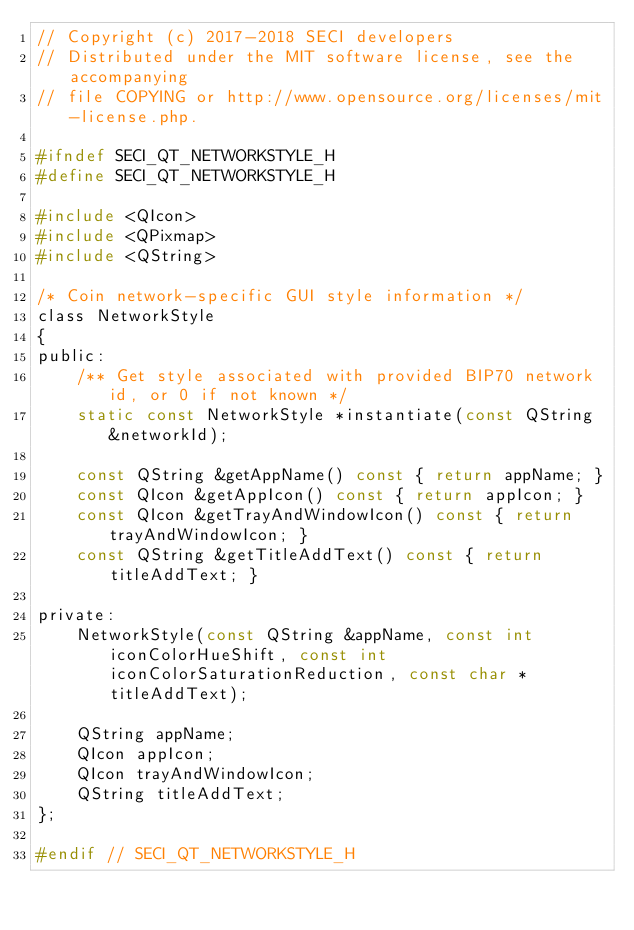<code> <loc_0><loc_0><loc_500><loc_500><_C_>// Copyright (c) 2017-2018 SECI developers
// Distributed under the MIT software license, see the accompanying
// file COPYING or http://www.opensource.org/licenses/mit-license.php.

#ifndef SECI_QT_NETWORKSTYLE_H
#define SECI_QT_NETWORKSTYLE_H

#include <QIcon>
#include <QPixmap>
#include <QString>

/* Coin network-specific GUI style information */
class NetworkStyle
{
public:
    /** Get style associated with provided BIP70 network id, or 0 if not known */
    static const NetworkStyle *instantiate(const QString &networkId);

    const QString &getAppName() const { return appName; }
    const QIcon &getAppIcon() const { return appIcon; }
    const QIcon &getTrayAndWindowIcon() const { return trayAndWindowIcon; }
    const QString &getTitleAddText() const { return titleAddText; }

private:
    NetworkStyle(const QString &appName, const int iconColorHueShift, const int iconColorSaturationReduction, const char *titleAddText);

    QString appName;
    QIcon appIcon;
    QIcon trayAndWindowIcon;
    QString titleAddText;
};

#endif // SECI_QT_NETWORKSTYLE_H
</code> 